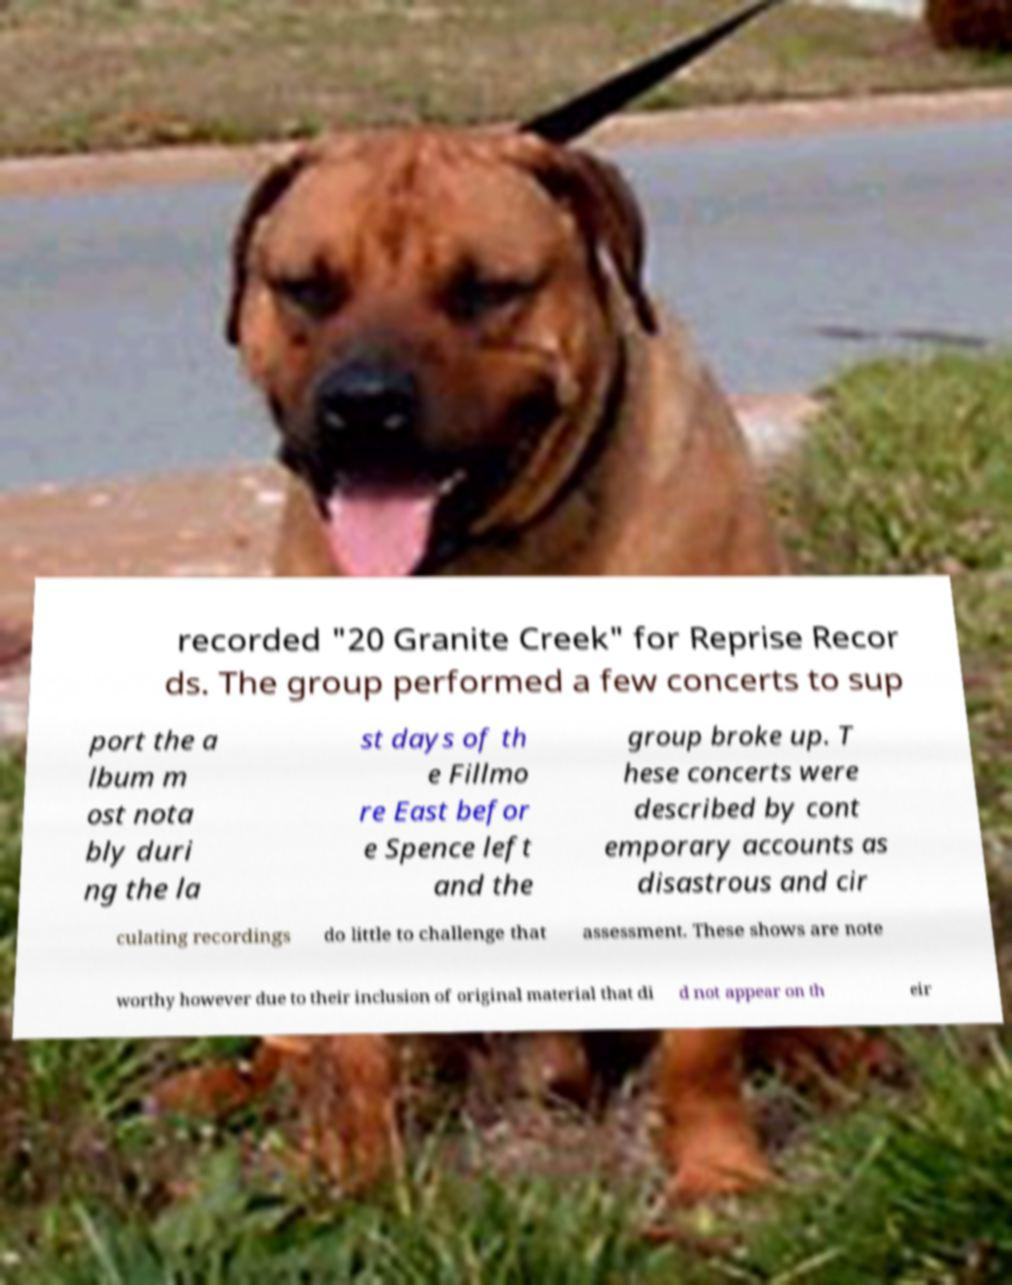Please identify and transcribe the text found in this image. recorded "20 Granite Creek" for Reprise Recor ds. The group performed a few concerts to sup port the a lbum m ost nota bly duri ng the la st days of th e Fillmo re East befor e Spence left and the group broke up. T hese concerts were described by cont emporary accounts as disastrous and cir culating recordings do little to challenge that assessment. These shows are note worthy however due to their inclusion of original material that di d not appear on th eir 